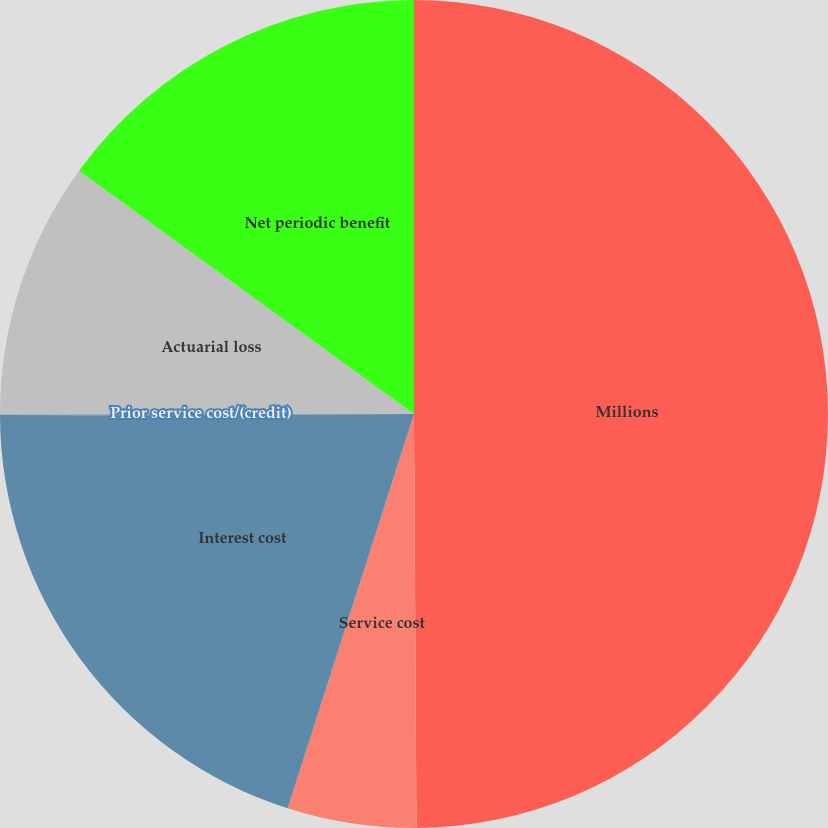Convert chart. <chart><loc_0><loc_0><loc_500><loc_500><pie_chart><fcel>Millions<fcel>Service cost<fcel>Interest cost<fcel>Prior service cost/(credit)<fcel>Actuarial loss<fcel>Net periodic benefit<nl><fcel>49.9%<fcel>5.03%<fcel>19.99%<fcel>0.05%<fcel>10.02%<fcel>15.0%<nl></chart> 